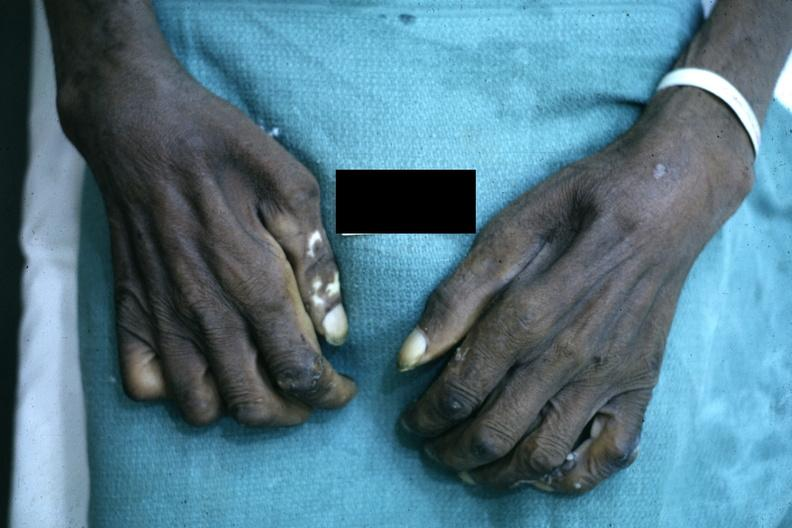s close-up excellent example of interosseous muscle atrophy said to be due to syringomyelus?
Answer the question using a single word or phrase. Yes 